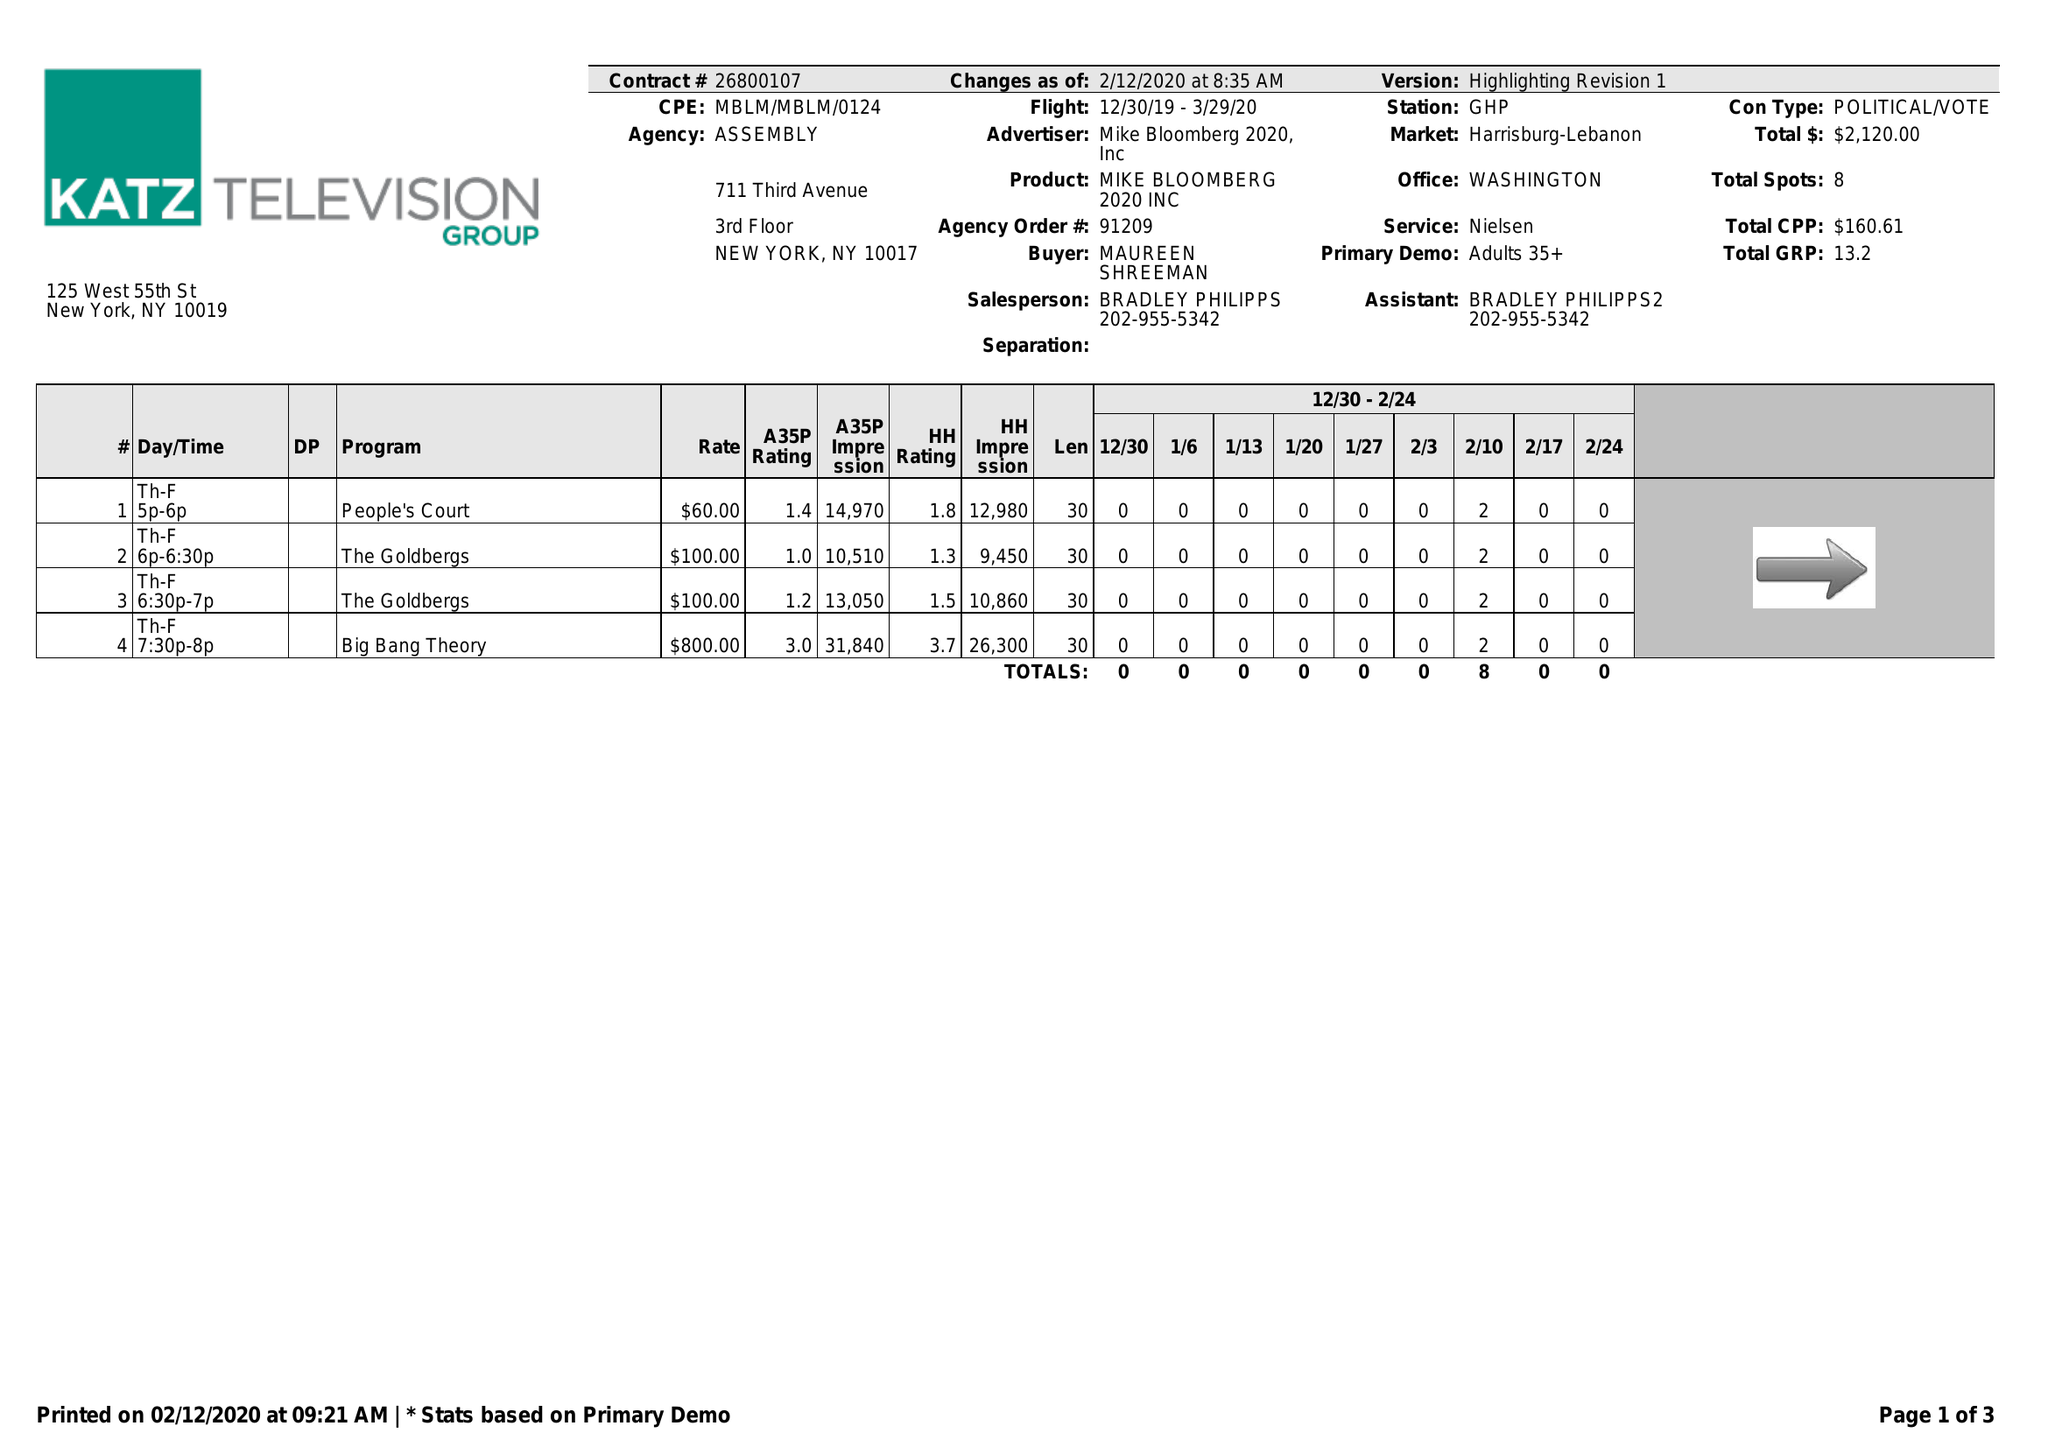What is the value for the flight_to?
Answer the question using a single word or phrase. 03/29/20 